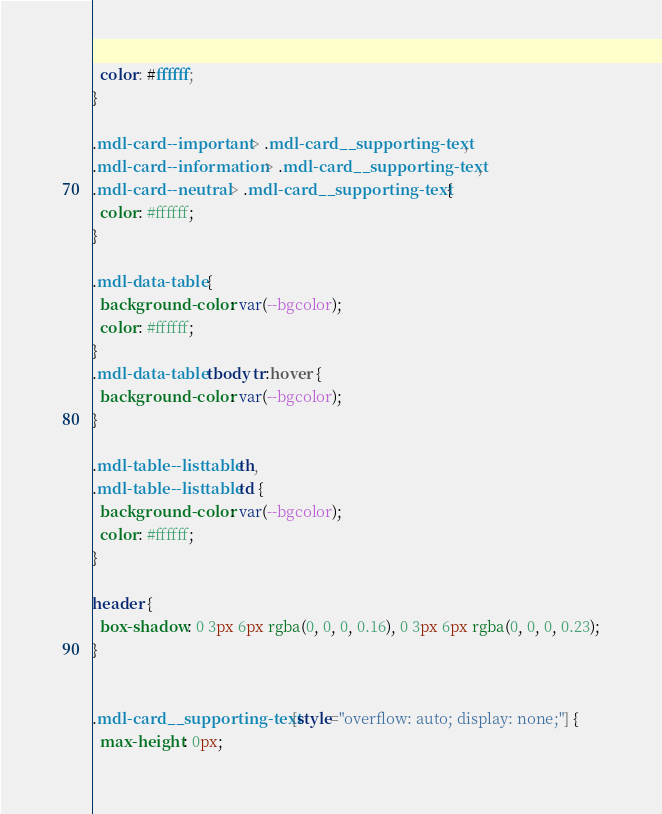Convert code to text. <code><loc_0><loc_0><loc_500><loc_500><_CSS_>  color: #ffffff;
}

.mdl-card--important > .mdl-card__supporting-text,
.mdl-card--information > .mdl-card__supporting-text,
.mdl-card--neutral > .mdl-card__supporting-text {
  color: #ffffff;
}

.mdl-data-table {
  background-color: var(--bgcolor);
  color: #ffffff;
}
.mdl-data-table tbody tr:hover {
  background-color: var(--bgcolor);
}

.mdl-table--listtable th,
.mdl-table--listtable td {
  background-color: var(--bgcolor);
  color: #ffffff;
}

header {
  box-shadow: 0 3px 6px rgba(0, 0, 0, 0.16), 0 3px 6px rgba(0, 0, 0, 0.23);
}


.mdl-card__supporting-text[style="overflow: auto; display: none;"] {
  max-height: 0px;</code> 